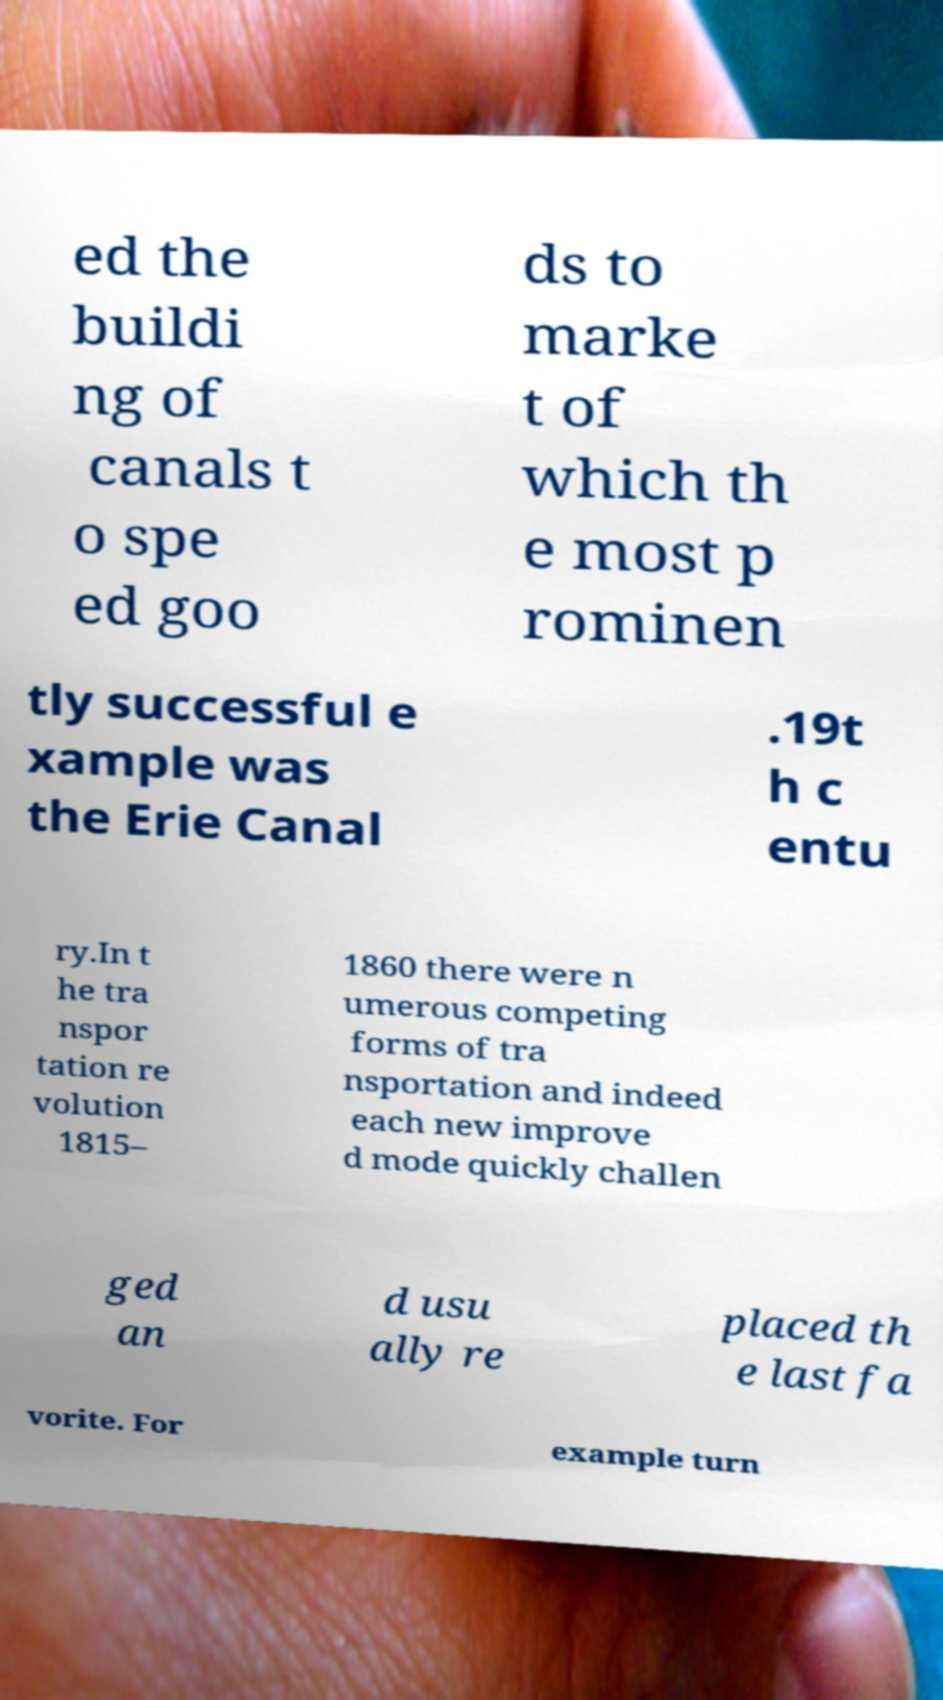Can you accurately transcribe the text from the provided image for me? ed the buildi ng of canals t o spe ed goo ds to marke t of which th e most p rominen tly successful e xample was the Erie Canal .19t h c entu ry.In t he tra nspor tation re volution 1815– 1860 there were n umerous competing forms of tra nsportation and indeed each new improve d mode quickly challen ged an d usu ally re placed th e last fa vorite. For example turn 